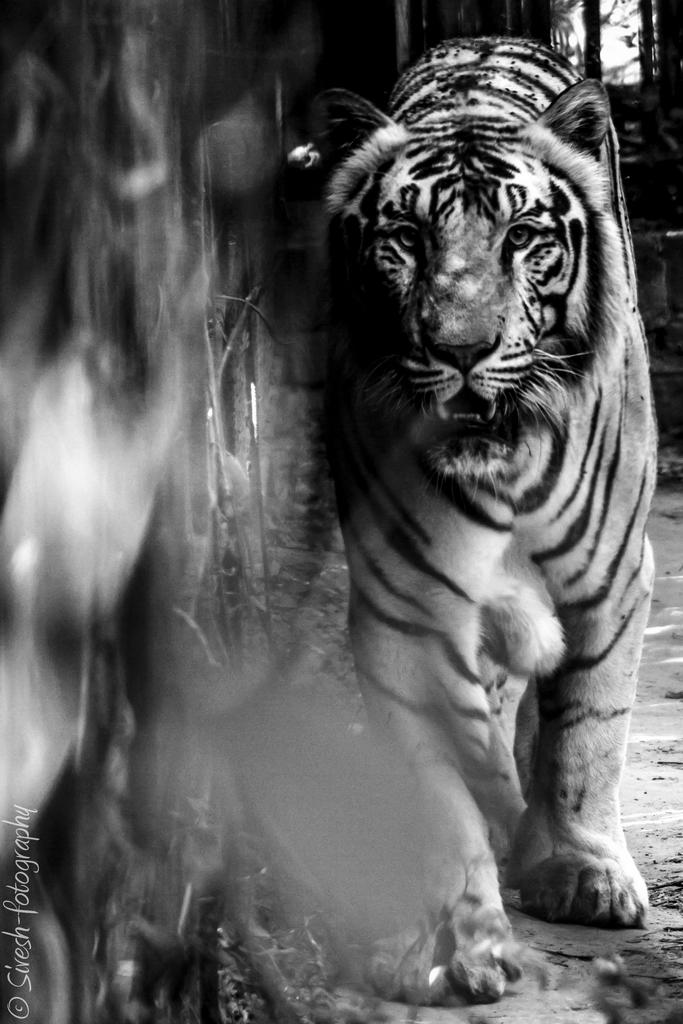What animal is in the picture? There is a tiger in the picture. What is the tiger doing in the picture? The tiger is walking. What can be seen in the background of the picture? There is a wall in the picture. What type of music is the tiger listening to while walking in the picture? There is no indication in the image that the tiger is listening to music, as animals do not have the ability to listen to or appreciate music. 